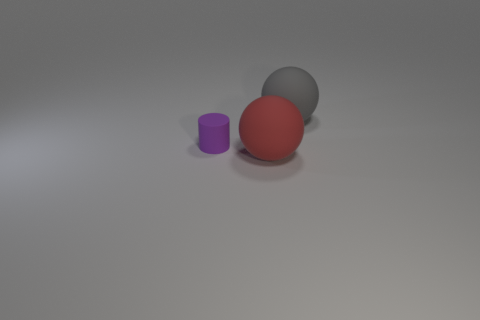Add 2 large gray matte objects. How many objects exist? 5 Subtract all balls. How many objects are left? 1 Subtract all big rubber objects. Subtract all large red matte objects. How many objects are left? 0 Add 2 purple matte cylinders. How many purple matte cylinders are left? 3 Add 1 large balls. How many large balls exist? 3 Subtract 1 red spheres. How many objects are left? 2 